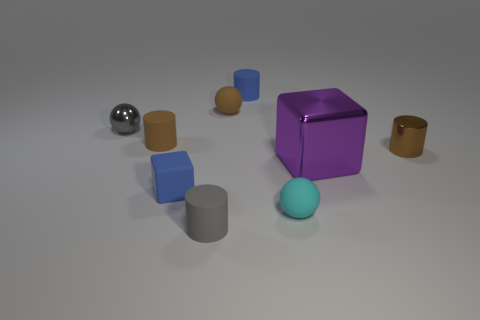Is there anything else that is the same size as the purple block?
Your answer should be very brief. No. There is a large thing; is it the same shape as the blue rubber object in front of the tiny blue rubber cylinder?
Ensure brevity in your answer.  Yes. What is the tiny blue cube made of?
Offer a terse response. Rubber. What number of matte objects are either small gray cylinders or big blocks?
Offer a terse response. 1. Is the number of gray metallic balls that are in front of the small cyan rubber thing less than the number of cyan things left of the large purple metal thing?
Give a very brief answer. Yes. Is there a small matte object that is in front of the small blue matte object in front of the tiny brown cylinder that is on the right side of the rubber block?
Provide a succinct answer. Yes. There is a small thing that is the same color as the small metallic ball; what material is it?
Offer a very short reply. Rubber. Does the blue rubber thing that is behind the gray sphere have the same shape as the brown thing left of the tiny matte block?
Ensure brevity in your answer.  Yes. There is a gray sphere that is the same size as the cyan ball; what is it made of?
Provide a succinct answer. Metal. Are the cylinder on the right side of the tiny cyan sphere and the tiny ball that is behind the tiny gray sphere made of the same material?
Your answer should be compact. No. 